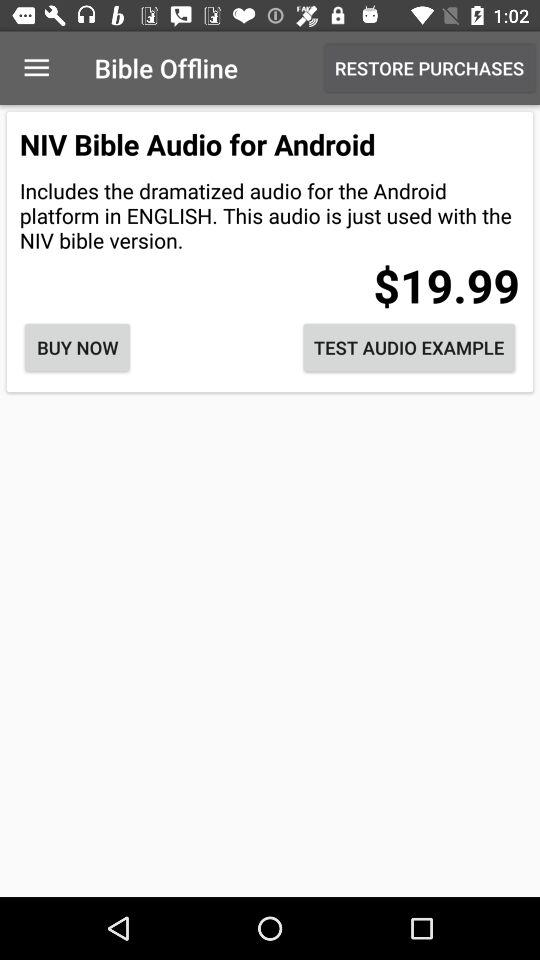What is the cost of the "NIV Bible Audio" for Android? The cost is $19.99. 